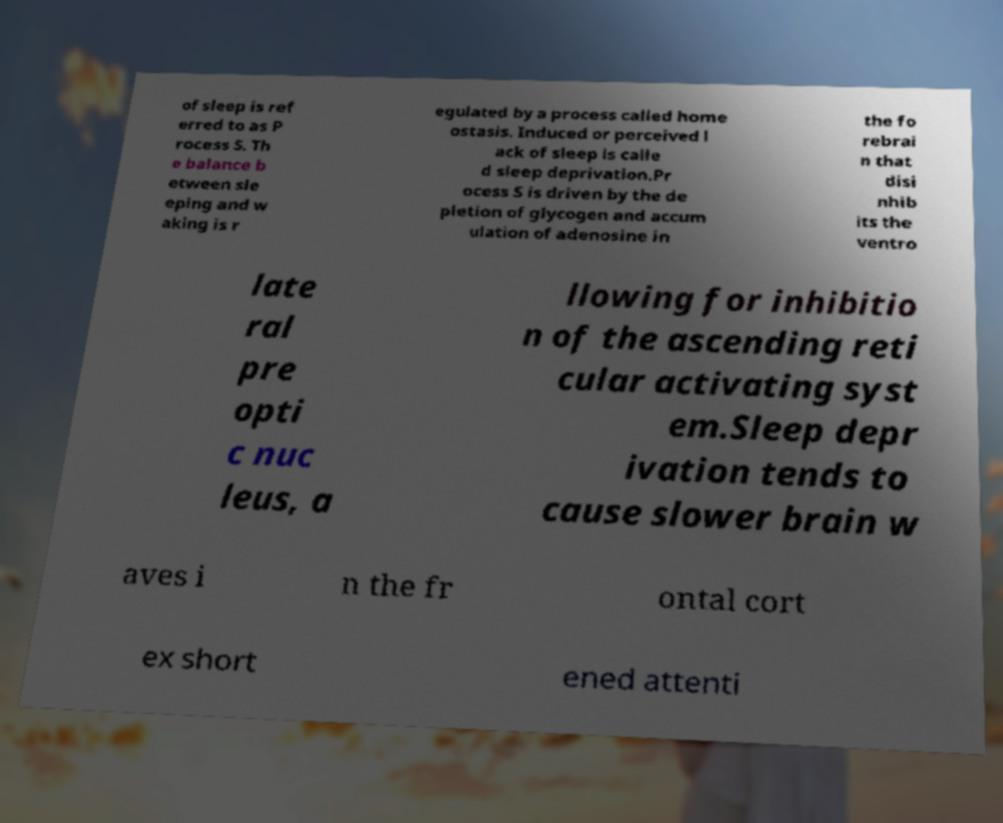Please identify and transcribe the text found in this image. of sleep is ref erred to as P rocess S. Th e balance b etween sle eping and w aking is r egulated by a process called home ostasis. Induced or perceived l ack of sleep is calle d sleep deprivation.Pr ocess S is driven by the de pletion of glycogen and accum ulation of adenosine in the fo rebrai n that disi nhib its the ventro late ral pre opti c nuc leus, a llowing for inhibitio n of the ascending reti cular activating syst em.Sleep depr ivation tends to cause slower brain w aves i n the fr ontal cort ex short ened attenti 